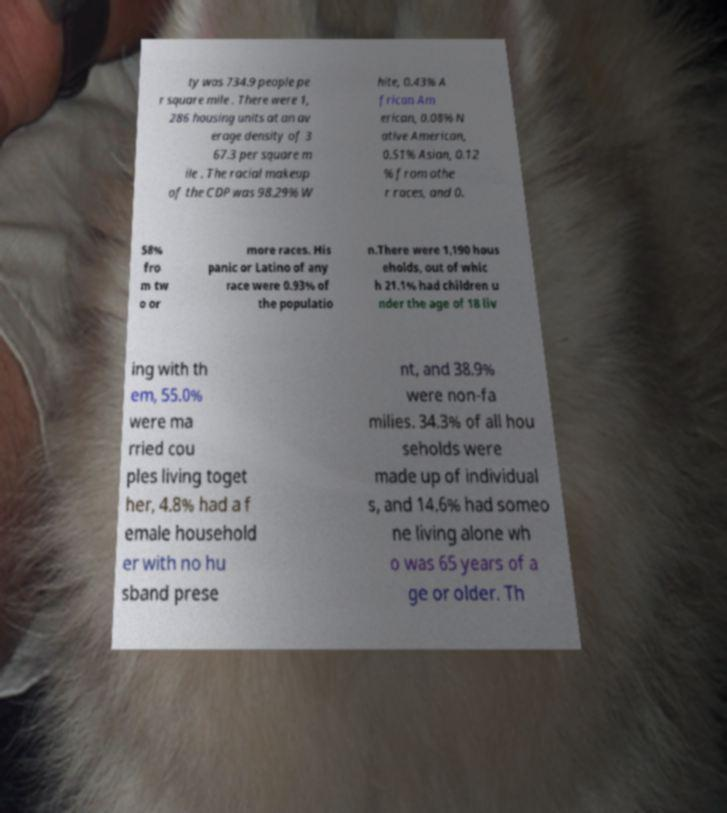Can you accurately transcribe the text from the provided image for me? ty was 734.9 people pe r square mile . There were 1, 286 housing units at an av erage density of 3 67.3 per square m ile . The racial makeup of the CDP was 98.29% W hite, 0.43% A frican Am erican, 0.08% N ative American, 0.51% Asian, 0.12 % from othe r races, and 0. 58% fro m tw o or more races. His panic or Latino of any race were 0.93% of the populatio n.There were 1,190 hous eholds, out of whic h 21.1% had children u nder the age of 18 liv ing with th em, 55.0% were ma rried cou ples living toget her, 4.8% had a f emale household er with no hu sband prese nt, and 38.9% were non-fa milies. 34.3% of all hou seholds were made up of individual s, and 14.6% had someo ne living alone wh o was 65 years of a ge or older. Th 